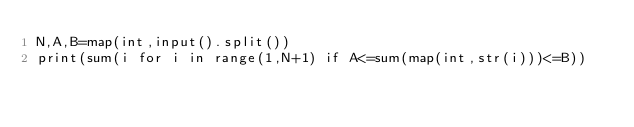Convert code to text. <code><loc_0><loc_0><loc_500><loc_500><_Scheme_>N,A,B=map(int,input().split())
print(sum(i for i in range(1,N+1) if A<=sum(map(int,str(i)))<=B))</code> 